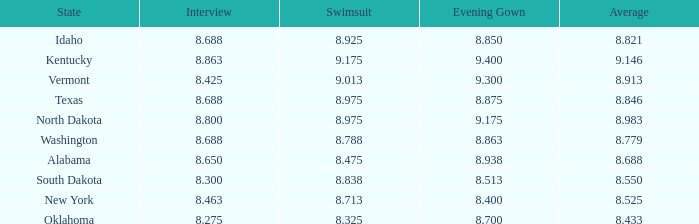What is the maximum swimsuit score for a participant with an evening dress greater than None. 